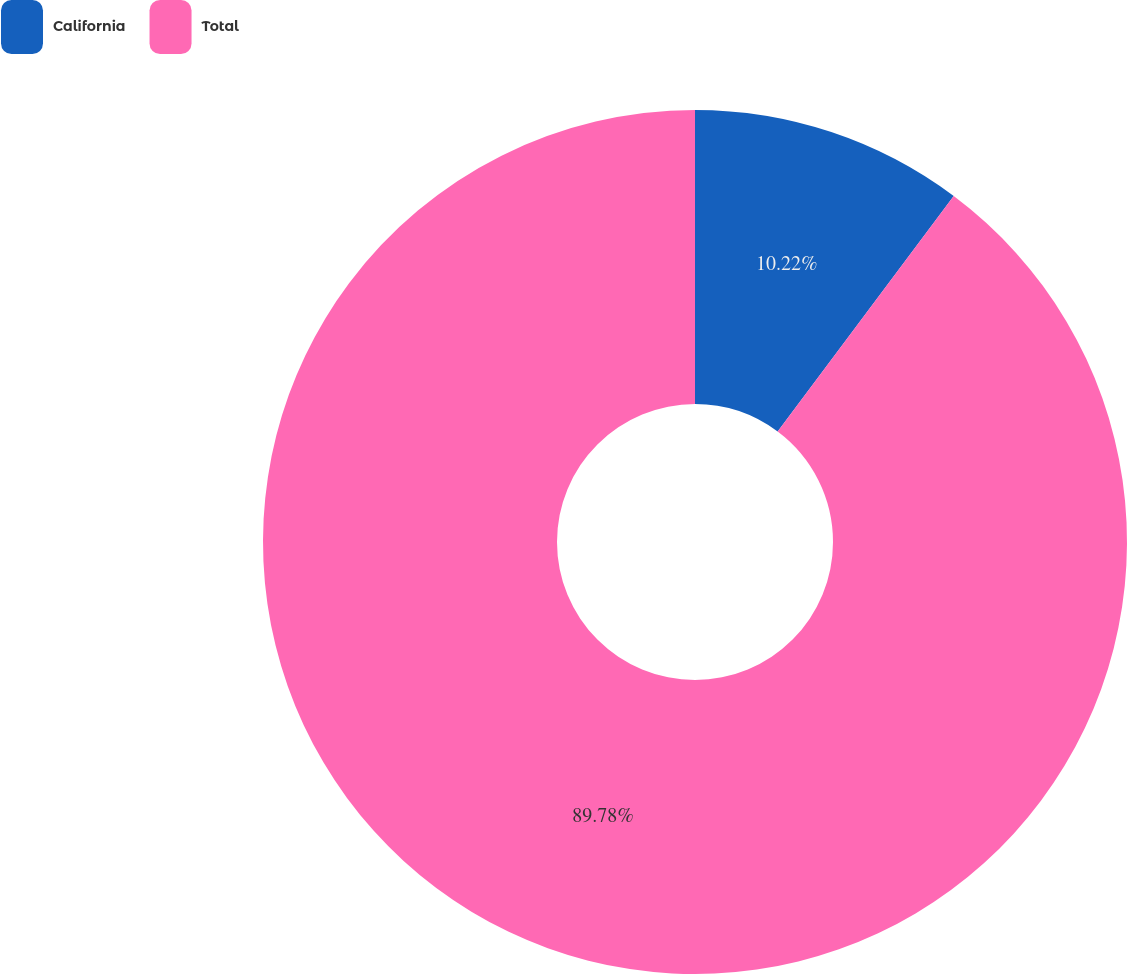Convert chart. <chart><loc_0><loc_0><loc_500><loc_500><pie_chart><fcel>California<fcel>Total<nl><fcel>10.22%<fcel>89.78%<nl></chart> 